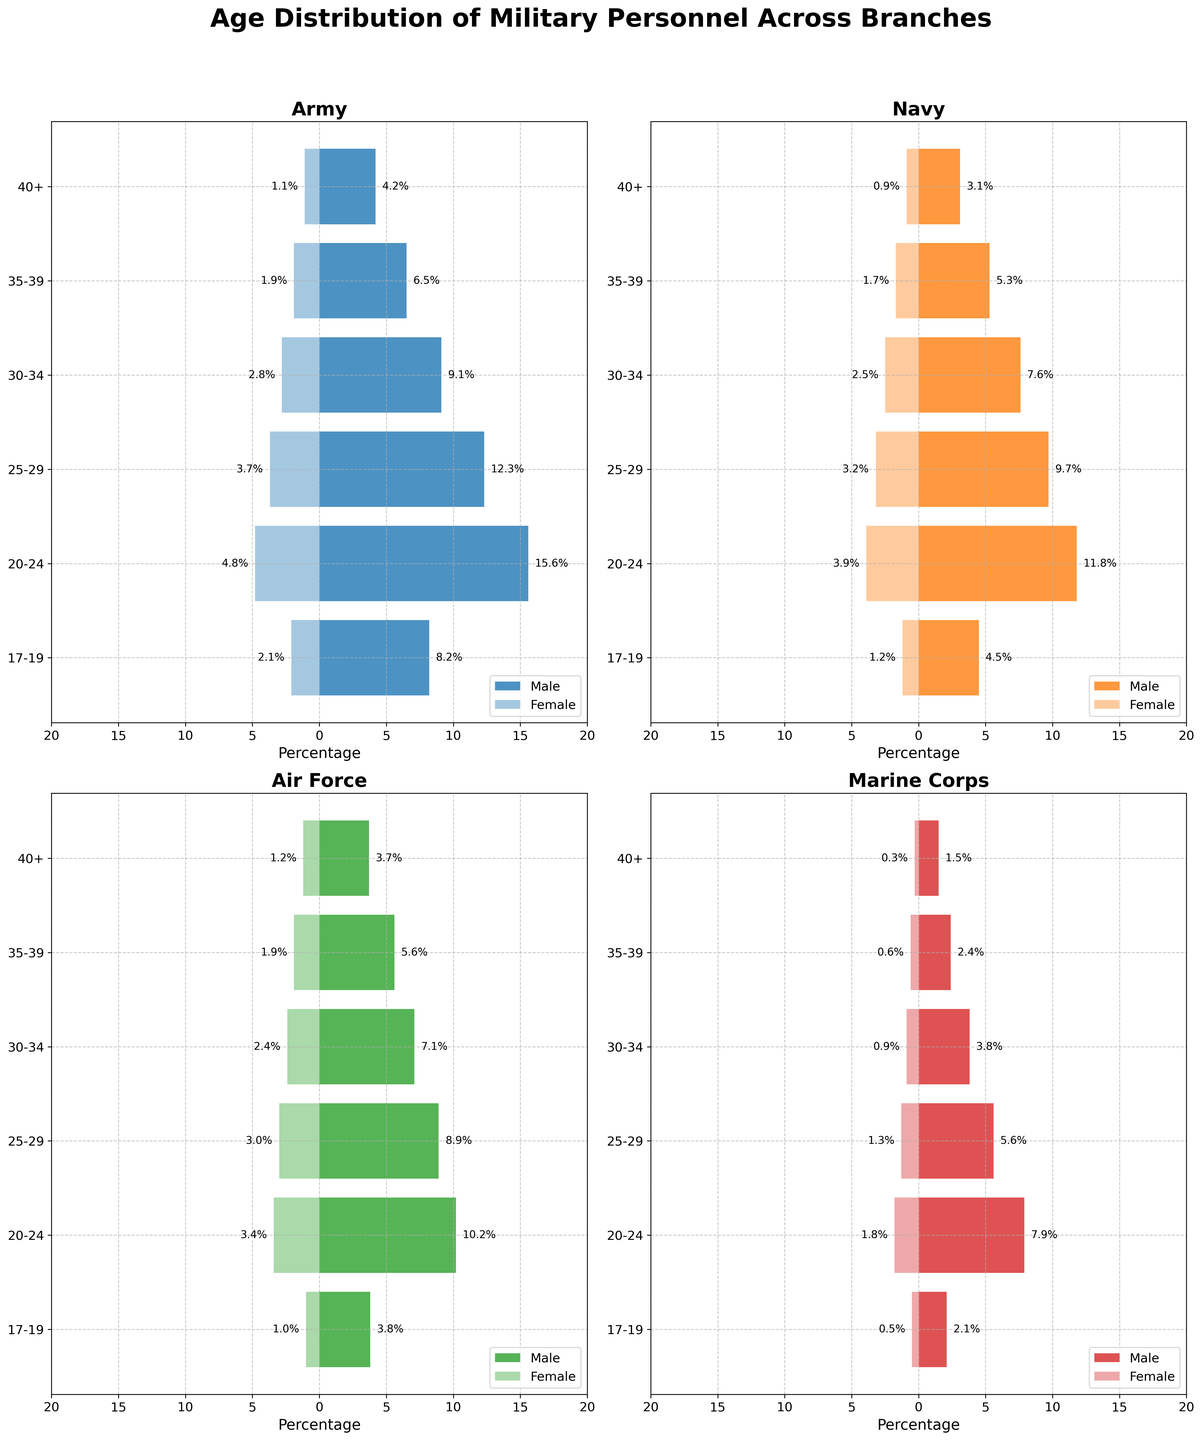Which branch has the highest percentage of males aged 17-19? To determine the branch with the highest percentage of males aged 17-19, look at the length of the bars for males in that age category across all branches. The Army has the longest bar at 8.2%.
Answer: Army Which age group has the smallest female percentage in the Marine Corps? Look at the female percentages for each age group in the Marine Corps. The 40+ age group has the smallest female percentage at 0.3%.
Answer: 40+ What is the total percentage of Navy personnel aged 25-29? Add the male and female percentages for Navy personnel in the 25-29 age group: 9.7% (male) + 3.2% (female) = 12.9%.
Answer: 12.9% How does the percentage of males aged 30-34 in the Air Force compare to the same age group in the Army? Compare the bar lengths for males aged 30-34 in both branches. The Air Force is at 7.1%, while the Army is at 9.1%, so the Army has a higher percentage.
Answer: The Army has a higher percentage What is the age group with the largest gender gap in the Navy? To find the age group with the largest gender gap, look at the differences between male and female percentages for each age group in the Navy. The 20-24 age group has the largest gender gap, with a difference of 11.8% (male) - 3.9% (female) = 7.9%.
Answer: 20-24 Which branch has the smallest percentage of females aged 25-29? To identify which branch has the smallest percentage of females aged 25-29, look at the bars for females in that age group across all branches. The Marine Corps has the smallest percentage at 1.3%.
Answer: Marine Corps What is the sum of the percentages of males aged 40+ across all branches? Add the male percentages aged 40+ for all branches: 4.2% (Army) + 3.1% (Navy) + 3.7% (Air Force) + 1.5% (Marine Corps) = 12.5%.
Answer: 12.5% Compare the total percentages of females aged 17-19 in the Army to those in the Navy. Look at the female percentages for the 17-19 age group in the Army and Navy. The Army has 2.1%, and the Navy has 1.2%, so the Army has a higher total percentage.
Answer: The Army has a higher total percentage What is the combined percentage of males and females aged 35-39 in the Air Force? Add the male and female percentages for the 35-39 age group in the Air Force: 5.6% (male) + 1.9% (female) = 7.5%.
Answer: 7.5% 